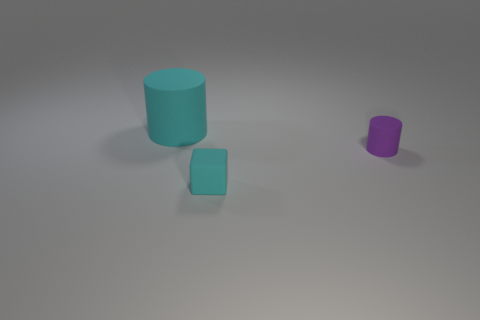Add 2 tiny yellow cylinders. How many objects exist? 5 Subtract all cylinders. How many objects are left? 1 Subtract 0 blue cylinders. How many objects are left? 3 Subtract all large cyan cylinders. Subtract all big cyan cylinders. How many objects are left? 1 Add 2 big matte objects. How many big matte objects are left? 3 Add 3 large cyan things. How many large cyan things exist? 4 